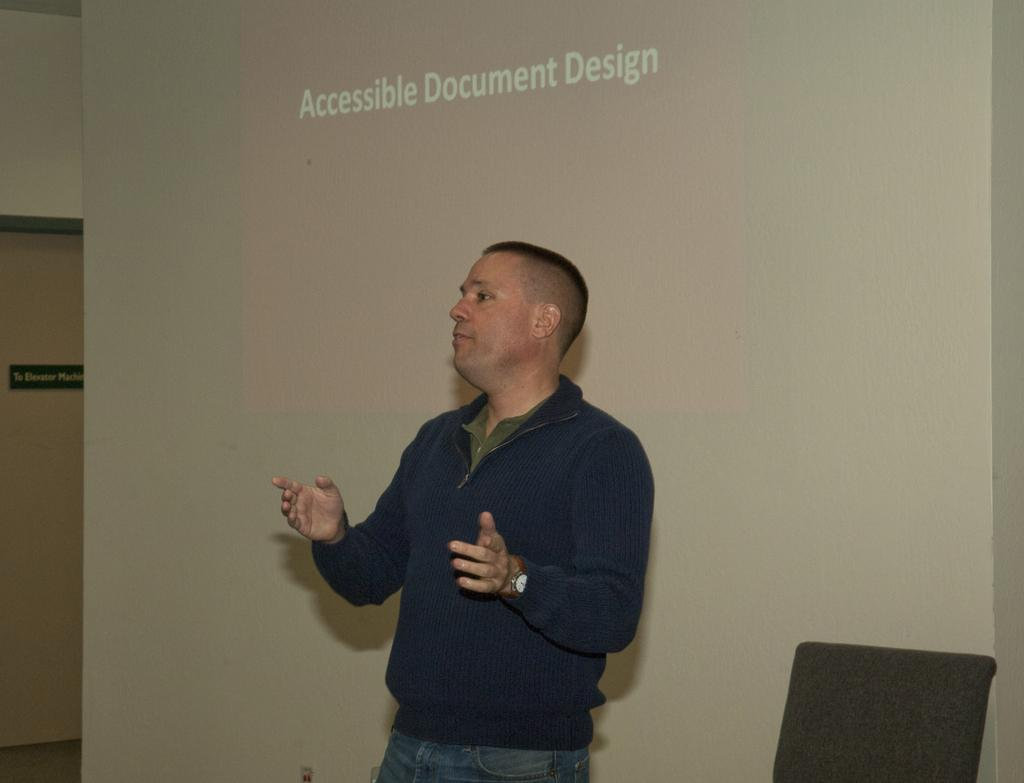What is the main subject of the image? There is a person standing and speaking in the center of the image. Can you describe any objects or furniture in the image? There is a chair on the right side of the image. What can be seen in the background of the image? The background of the image includes a wall painted white. Is there any entrance or exit visible in the image? Yes, there is a door on the left side of the image. What type of nail is being hammered into the wire in the image? There is no nail or wire present in the image; it features a person standing and speaking, a chair, a white wall, and a door. 